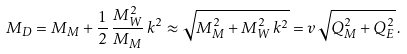<formula> <loc_0><loc_0><loc_500><loc_500>M _ { D } = M _ { M } + \frac { 1 } { 2 } \, \frac { M _ { W } ^ { 2 } } { M _ { M } } \, k ^ { 2 } \approx \sqrt { M _ { M } ^ { 2 } + M _ { W } ^ { 2 } \, k ^ { 2 } } = v \sqrt { Q _ { M } ^ { 2 } + Q _ { E } ^ { 2 } } \, .</formula> 